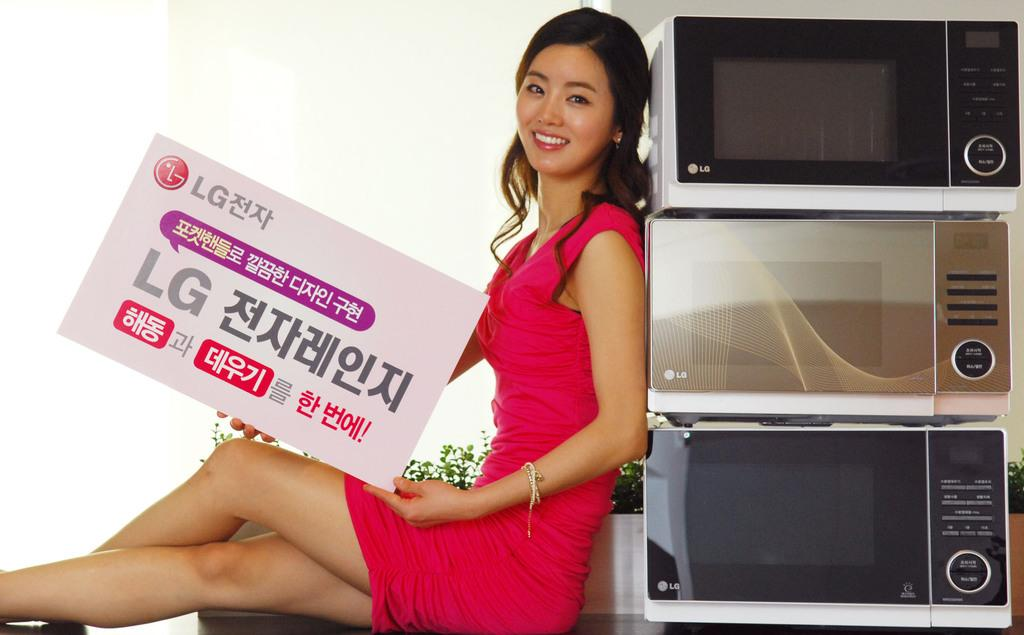<image>
Share a concise interpretation of the image provided. A model leans next to microwaves while holding a sign advertising for LG. 